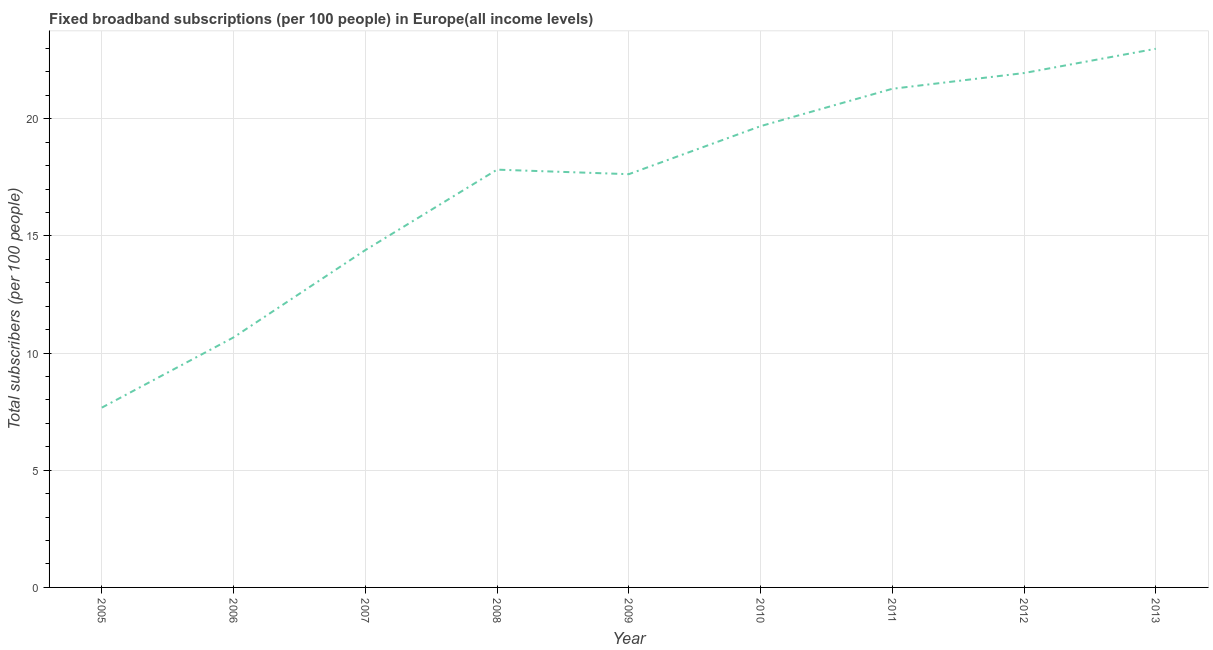What is the total number of fixed broadband subscriptions in 2010?
Keep it short and to the point. 19.68. Across all years, what is the maximum total number of fixed broadband subscriptions?
Your response must be concise. 22.98. Across all years, what is the minimum total number of fixed broadband subscriptions?
Give a very brief answer. 7.67. In which year was the total number of fixed broadband subscriptions maximum?
Offer a very short reply. 2013. What is the sum of the total number of fixed broadband subscriptions?
Offer a very short reply. 154.08. What is the difference between the total number of fixed broadband subscriptions in 2006 and 2009?
Provide a short and direct response. -6.96. What is the average total number of fixed broadband subscriptions per year?
Your answer should be compact. 17.12. What is the median total number of fixed broadband subscriptions?
Your answer should be very brief. 17.83. Do a majority of the years between 2010 and 2005 (inclusive) have total number of fixed broadband subscriptions greater than 4 ?
Keep it short and to the point. Yes. What is the ratio of the total number of fixed broadband subscriptions in 2011 to that in 2013?
Offer a terse response. 0.93. Is the difference between the total number of fixed broadband subscriptions in 2008 and 2013 greater than the difference between any two years?
Your response must be concise. No. What is the difference between the highest and the second highest total number of fixed broadband subscriptions?
Make the answer very short. 1.04. What is the difference between the highest and the lowest total number of fixed broadband subscriptions?
Provide a short and direct response. 15.31. In how many years, is the total number of fixed broadband subscriptions greater than the average total number of fixed broadband subscriptions taken over all years?
Keep it short and to the point. 6. How many lines are there?
Ensure brevity in your answer.  1. How many years are there in the graph?
Your answer should be very brief. 9. What is the difference between two consecutive major ticks on the Y-axis?
Give a very brief answer. 5. Are the values on the major ticks of Y-axis written in scientific E-notation?
Give a very brief answer. No. Does the graph contain any zero values?
Your answer should be very brief. No. Does the graph contain grids?
Make the answer very short. Yes. What is the title of the graph?
Ensure brevity in your answer.  Fixed broadband subscriptions (per 100 people) in Europe(all income levels). What is the label or title of the Y-axis?
Make the answer very short. Total subscribers (per 100 people). What is the Total subscribers (per 100 people) of 2005?
Offer a very short reply. 7.67. What is the Total subscribers (per 100 people) of 2006?
Your response must be concise. 10.67. What is the Total subscribers (per 100 people) in 2007?
Give a very brief answer. 14.39. What is the Total subscribers (per 100 people) of 2008?
Make the answer very short. 17.83. What is the Total subscribers (per 100 people) of 2009?
Offer a very short reply. 17.63. What is the Total subscribers (per 100 people) of 2010?
Provide a succinct answer. 19.68. What is the Total subscribers (per 100 people) in 2011?
Offer a terse response. 21.28. What is the Total subscribers (per 100 people) in 2012?
Offer a very short reply. 21.95. What is the Total subscribers (per 100 people) in 2013?
Provide a succinct answer. 22.98. What is the difference between the Total subscribers (per 100 people) in 2005 and 2006?
Make the answer very short. -3. What is the difference between the Total subscribers (per 100 people) in 2005 and 2007?
Offer a very short reply. -6.72. What is the difference between the Total subscribers (per 100 people) in 2005 and 2008?
Keep it short and to the point. -10.15. What is the difference between the Total subscribers (per 100 people) in 2005 and 2009?
Provide a succinct answer. -9.96. What is the difference between the Total subscribers (per 100 people) in 2005 and 2010?
Ensure brevity in your answer.  -12.01. What is the difference between the Total subscribers (per 100 people) in 2005 and 2011?
Make the answer very short. -13.61. What is the difference between the Total subscribers (per 100 people) in 2005 and 2012?
Your response must be concise. -14.28. What is the difference between the Total subscribers (per 100 people) in 2005 and 2013?
Give a very brief answer. -15.31. What is the difference between the Total subscribers (per 100 people) in 2006 and 2007?
Your answer should be compact. -3.72. What is the difference between the Total subscribers (per 100 people) in 2006 and 2008?
Offer a very short reply. -7.16. What is the difference between the Total subscribers (per 100 people) in 2006 and 2009?
Give a very brief answer. -6.96. What is the difference between the Total subscribers (per 100 people) in 2006 and 2010?
Make the answer very short. -9.01. What is the difference between the Total subscribers (per 100 people) in 2006 and 2011?
Offer a very short reply. -10.61. What is the difference between the Total subscribers (per 100 people) in 2006 and 2012?
Your answer should be very brief. -11.28. What is the difference between the Total subscribers (per 100 people) in 2006 and 2013?
Offer a very short reply. -12.31. What is the difference between the Total subscribers (per 100 people) in 2007 and 2008?
Your answer should be compact. -3.43. What is the difference between the Total subscribers (per 100 people) in 2007 and 2009?
Your answer should be compact. -3.24. What is the difference between the Total subscribers (per 100 people) in 2007 and 2010?
Your answer should be very brief. -5.29. What is the difference between the Total subscribers (per 100 people) in 2007 and 2011?
Your answer should be compact. -6.88. What is the difference between the Total subscribers (per 100 people) in 2007 and 2012?
Your response must be concise. -7.56. What is the difference between the Total subscribers (per 100 people) in 2007 and 2013?
Offer a very short reply. -8.59. What is the difference between the Total subscribers (per 100 people) in 2008 and 2009?
Give a very brief answer. 0.19. What is the difference between the Total subscribers (per 100 people) in 2008 and 2010?
Provide a short and direct response. -1.86. What is the difference between the Total subscribers (per 100 people) in 2008 and 2011?
Offer a very short reply. -3.45. What is the difference between the Total subscribers (per 100 people) in 2008 and 2012?
Offer a very short reply. -4.12. What is the difference between the Total subscribers (per 100 people) in 2008 and 2013?
Offer a terse response. -5.16. What is the difference between the Total subscribers (per 100 people) in 2009 and 2010?
Provide a short and direct response. -2.05. What is the difference between the Total subscribers (per 100 people) in 2009 and 2011?
Provide a short and direct response. -3.64. What is the difference between the Total subscribers (per 100 people) in 2009 and 2012?
Make the answer very short. -4.32. What is the difference between the Total subscribers (per 100 people) in 2009 and 2013?
Provide a short and direct response. -5.35. What is the difference between the Total subscribers (per 100 people) in 2010 and 2011?
Give a very brief answer. -1.59. What is the difference between the Total subscribers (per 100 people) in 2010 and 2012?
Keep it short and to the point. -2.27. What is the difference between the Total subscribers (per 100 people) in 2010 and 2013?
Keep it short and to the point. -3.3. What is the difference between the Total subscribers (per 100 people) in 2011 and 2012?
Offer a terse response. -0.67. What is the difference between the Total subscribers (per 100 people) in 2011 and 2013?
Ensure brevity in your answer.  -1.71. What is the difference between the Total subscribers (per 100 people) in 2012 and 2013?
Offer a very short reply. -1.04. What is the ratio of the Total subscribers (per 100 people) in 2005 to that in 2006?
Provide a short and direct response. 0.72. What is the ratio of the Total subscribers (per 100 people) in 2005 to that in 2007?
Ensure brevity in your answer.  0.53. What is the ratio of the Total subscribers (per 100 people) in 2005 to that in 2008?
Give a very brief answer. 0.43. What is the ratio of the Total subscribers (per 100 people) in 2005 to that in 2009?
Give a very brief answer. 0.43. What is the ratio of the Total subscribers (per 100 people) in 2005 to that in 2010?
Provide a succinct answer. 0.39. What is the ratio of the Total subscribers (per 100 people) in 2005 to that in 2011?
Ensure brevity in your answer.  0.36. What is the ratio of the Total subscribers (per 100 people) in 2005 to that in 2013?
Your answer should be compact. 0.33. What is the ratio of the Total subscribers (per 100 people) in 2006 to that in 2007?
Provide a short and direct response. 0.74. What is the ratio of the Total subscribers (per 100 people) in 2006 to that in 2008?
Your answer should be compact. 0.6. What is the ratio of the Total subscribers (per 100 people) in 2006 to that in 2009?
Your answer should be very brief. 0.6. What is the ratio of the Total subscribers (per 100 people) in 2006 to that in 2010?
Your answer should be compact. 0.54. What is the ratio of the Total subscribers (per 100 people) in 2006 to that in 2011?
Give a very brief answer. 0.5. What is the ratio of the Total subscribers (per 100 people) in 2006 to that in 2012?
Keep it short and to the point. 0.49. What is the ratio of the Total subscribers (per 100 people) in 2006 to that in 2013?
Keep it short and to the point. 0.46. What is the ratio of the Total subscribers (per 100 people) in 2007 to that in 2008?
Your answer should be compact. 0.81. What is the ratio of the Total subscribers (per 100 people) in 2007 to that in 2009?
Offer a very short reply. 0.82. What is the ratio of the Total subscribers (per 100 people) in 2007 to that in 2010?
Offer a very short reply. 0.73. What is the ratio of the Total subscribers (per 100 people) in 2007 to that in 2011?
Your answer should be compact. 0.68. What is the ratio of the Total subscribers (per 100 people) in 2007 to that in 2012?
Make the answer very short. 0.66. What is the ratio of the Total subscribers (per 100 people) in 2007 to that in 2013?
Ensure brevity in your answer.  0.63. What is the ratio of the Total subscribers (per 100 people) in 2008 to that in 2009?
Give a very brief answer. 1.01. What is the ratio of the Total subscribers (per 100 people) in 2008 to that in 2010?
Offer a very short reply. 0.91. What is the ratio of the Total subscribers (per 100 people) in 2008 to that in 2011?
Keep it short and to the point. 0.84. What is the ratio of the Total subscribers (per 100 people) in 2008 to that in 2012?
Your answer should be compact. 0.81. What is the ratio of the Total subscribers (per 100 people) in 2008 to that in 2013?
Your answer should be very brief. 0.78. What is the ratio of the Total subscribers (per 100 people) in 2009 to that in 2010?
Offer a terse response. 0.9. What is the ratio of the Total subscribers (per 100 people) in 2009 to that in 2011?
Ensure brevity in your answer.  0.83. What is the ratio of the Total subscribers (per 100 people) in 2009 to that in 2012?
Offer a terse response. 0.8. What is the ratio of the Total subscribers (per 100 people) in 2009 to that in 2013?
Offer a terse response. 0.77. What is the ratio of the Total subscribers (per 100 people) in 2010 to that in 2011?
Your answer should be compact. 0.93. What is the ratio of the Total subscribers (per 100 people) in 2010 to that in 2012?
Offer a very short reply. 0.9. What is the ratio of the Total subscribers (per 100 people) in 2010 to that in 2013?
Provide a succinct answer. 0.86. What is the ratio of the Total subscribers (per 100 people) in 2011 to that in 2012?
Offer a terse response. 0.97. What is the ratio of the Total subscribers (per 100 people) in 2011 to that in 2013?
Ensure brevity in your answer.  0.93. What is the ratio of the Total subscribers (per 100 people) in 2012 to that in 2013?
Your answer should be compact. 0.95. 